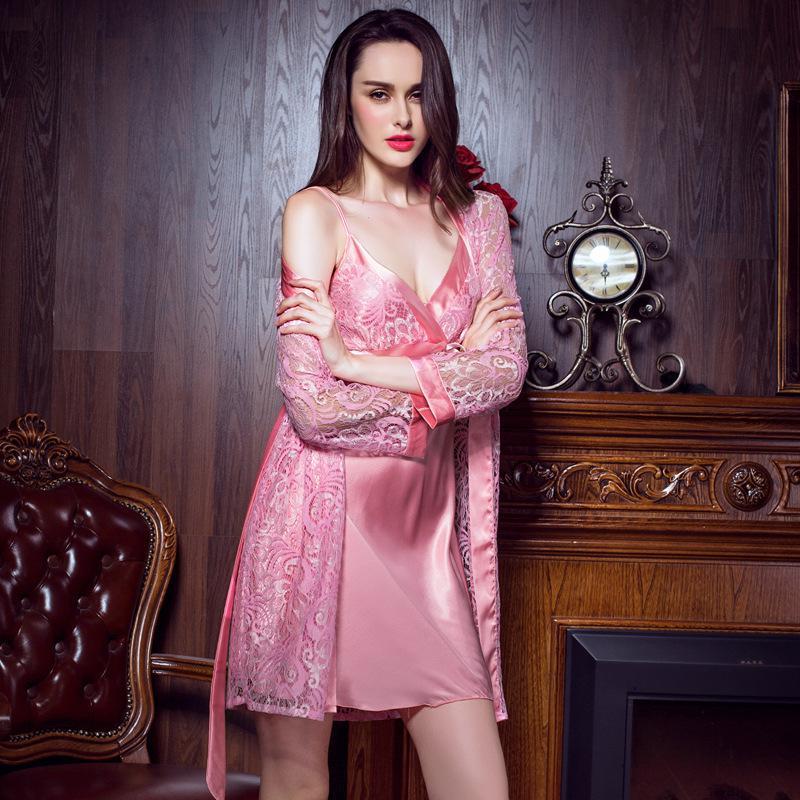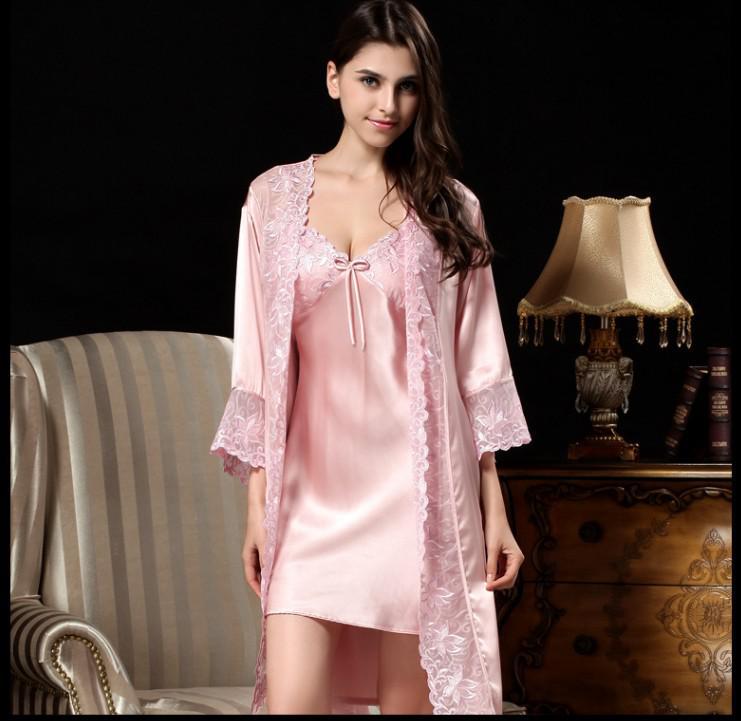The first image is the image on the left, the second image is the image on the right. Examine the images to the left and right. Is the description "In one of the images, the girl is sitting down" accurate? Answer yes or no. No. The first image is the image on the left, the second image is the image on the right. Analyze the images presented: Is the assertion "One woman is sitting on something." valid? Answer yes or no. No. 